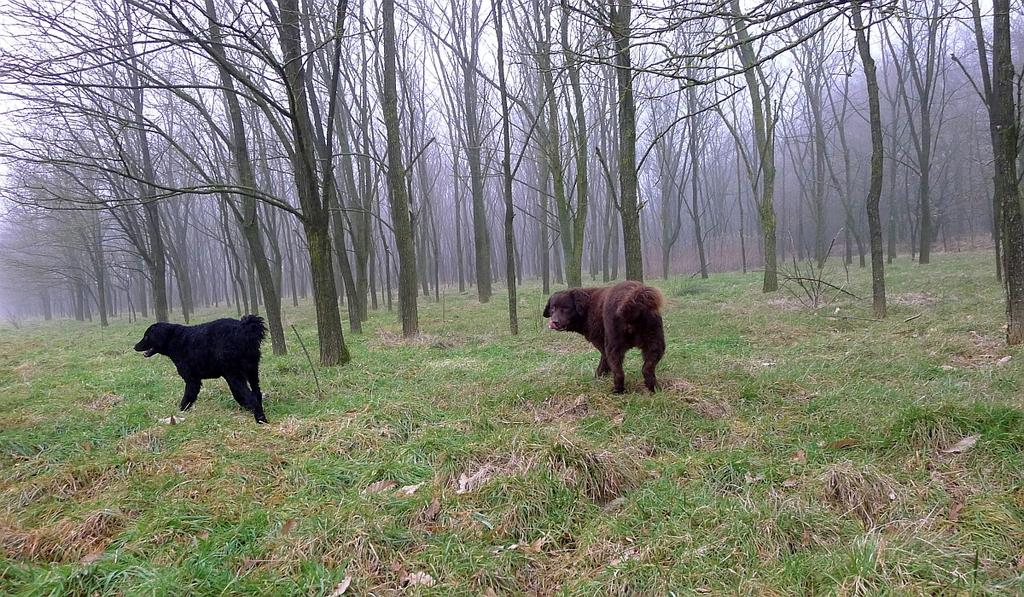What is the main subject in the center of the image? There is a dog in the center of the image. What type of terrain is visible at the bottom side of the image? There is grassland at the bottom side of the image. What type of vegetation is visible at the top side of the image? There are trees at the top side of the image. What hobbies does the dog have, as seen in the image? The image does not provide information about the dog's hobbies. Is the image taken during the summer season? The image does not provide information about the season or weather. 